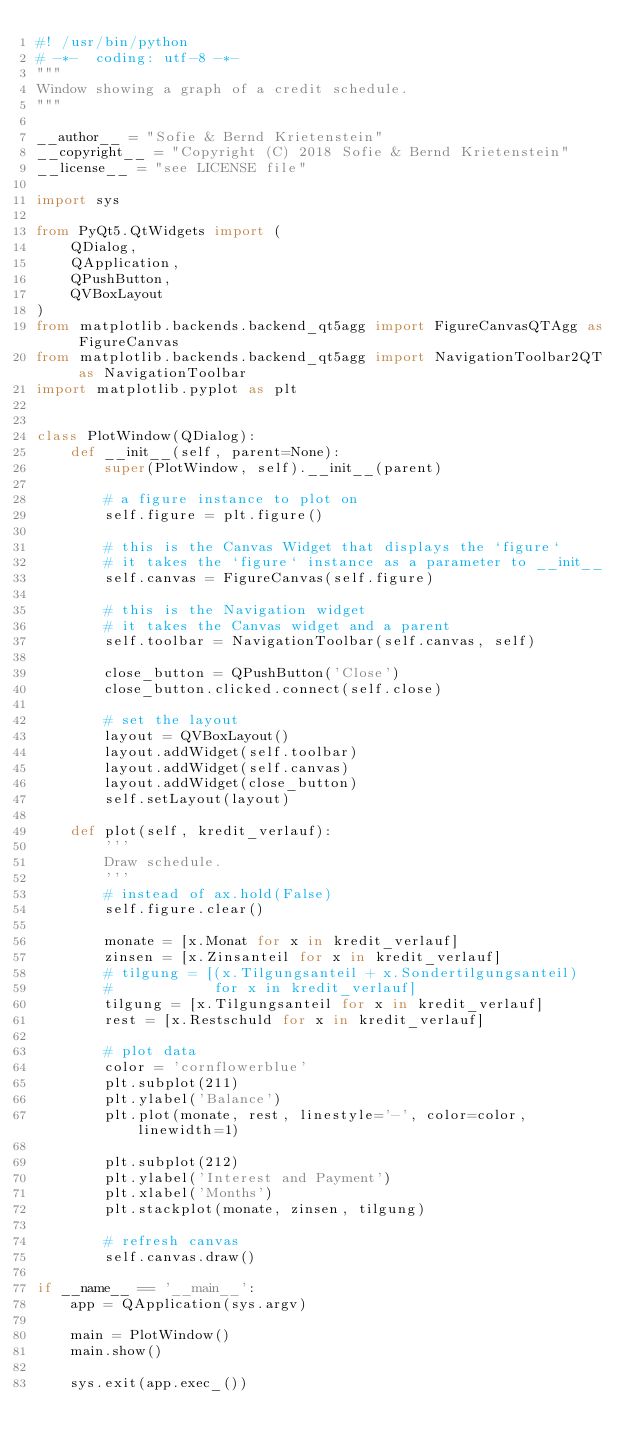Convert code to text. <code><loc_0><loc_0><loc_500><loc_500><_Python_>#! /usr/bin/python
# -*-  coding: utf-8 -*-
"""
Window showing a graph of a credit schedule.
"""

__author__ = "Sofie & Bernd Krietenstein"
__copyright__ = "Copyright (C) 2018 Sofie & Bernd Krietenstein"
__license__ = "see LICENSE file"

import sys

from PyQt5.QtWidgets import (
    QDialog,
    QApplication,
    QPushButton,
    QVBoxLayout
)
from matplotlib.backends.backend_qt5agg import FigureCanvasQTAgg as FigureCanvas
from matplotlib.backends.backend_qt5agg import NavigationToolbar2QT as NavigationToolbar
import matplotlib.pyplot as plt


class PlotWindow(QDialog):
    def __init__(self, parent=None):
        super(PlotWindow, self).__init__(parent)

        # a figure instance to plot on
        self.figure = plt.figure()

        # this is the Canvas Widget that displays the `figure`
        # it takes the `figure` instance as a parameter to __init__
        self.canvas = FigureCanvas(self.figure)

        # this is the Navigation widget
        # it takes the Canvas widget and a parent
        self.toolbar = NavigationToolbar(self.canvas, self)

        close_button = QPushButton('Close')
        close_button.clicked.connect(self.close)

        # set the layout
        layout = QVBoxLayout()
        layout.addWidget(self.toolbar)
        layout.addWidget(self.canvas)
        layout.addWidget(close_button)
        self.setLayout(layout)

    def plot(self, kredit_verlauf):
        '''
        Draw schedule.
        '''
        # instead of ax.hold(False)
        self.figure.clear()

        monate = [x.Monat for x in kredit_verlauf]
        zinsen = [x.Zinsanteil for x in kredit_verlauf]
        # tilgung = [(x.Tilgungsanteil + x.Sondertilgungsanteil)
        #            for x in kredit_verlauf]
        tilgung = [x.Tilgungsanteil for x in kredit_verlauf]
        rest = [x.Restschuld for x in kredit_verlauf]

        # plot data
        color = 'cornflowerblue'
        plt.subplot(211)
        plt.ylabel('Balance')
        plt.plot(monate, rest, linestyle='-', color=color, linewidth=1)

        plt.subplot(212)
        plt.ylabel('Interest and Payment')
        plt.xlabel('Months')
        plt.stackplot(monate, zinsen, tilgung)

        # refresh canvas
        self.canvas.draw()

if __name__ == '__main__':
    app = QApplication(sys.argv)

    main = PlotWindow()
    main.show()

    sys.exit(app.exec_())</code> 